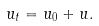Convert formula to latex. <formula><loc_0><loc_0><loc_500><loc_500>u _ { t } = u _ { 0 } + u .</formula> 